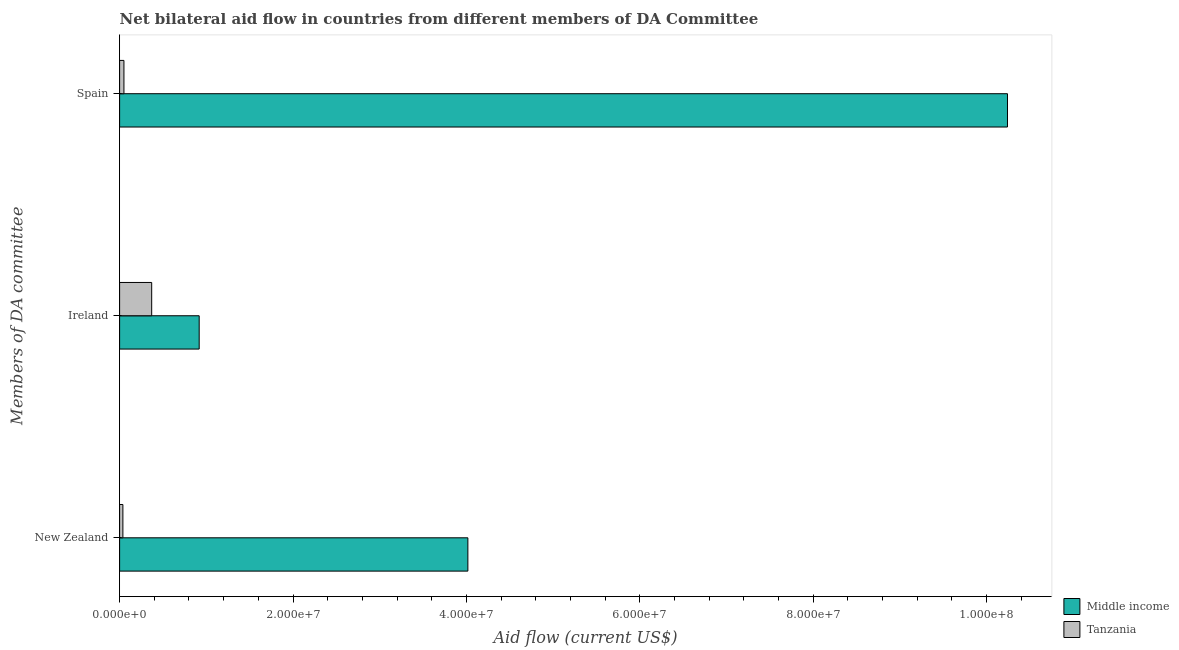Are the number of bars on each tick of the Y-axis equal?
Give a very brief answer. Yes. What is the amount of aid provided by new zealand in Middle income?
Ensure brevity in your answer.  4.02e+07. Across all countries, what is the maximum amount of aid provided by new zealand?
Keep it short and to the point. 4.02e+07. Across all countries, what is the minimum amount of aid provided by ireland?
Keep it short and to the point. 3.70e+06. In which country was the amount of aid provided by ireland maximum?
Provide a short and direct response. Middle income. In which country was the amount of aid provided by spain minimum?
Keep it short and to the point. Tanzania. What is the total amount of aid provided by spain in the graph?
Your answer should be compact. 1.03e+08. What is the difference between the amount of aid provided by new zealand in Tanzania and that in Middle income?
Offer a terse response. -3.98e+07. What is the difference between the amount of aid provided by new zealand in Tanzania and the amount of aid provided by ireland in Middle income?
Your answer should be very brief. -8.80e+06. What is the average amount of aid provided by spain per country?
Keep it short and to the point. 5.15e+07. What is the difference between the amount of aid provided by ireland and amount of aid provided by new zealand in Middle income?
Your answer should be compact. -3.10e+07. In how many countries, is the amount of aid provided by spain greater than 36000000 US$?
Provide a succinct answer. 1. What is the ratio of the amount of aid provided by spain in Tanzania to that in Middle income?
Make the answer very short. 0. Is the amount of aid provided by new zealand in Middle income less than that in Tanzania?
Your answer should be very brief. No. What is the difference between the highest and the second highest amount of aid provided by spain?
Your answer should be very brief. 1.02e+08. What is the difference between the highest and the lowest amount of aid provided by new zealand?
Offer a terse response. 3.98e+07. In how many countries, is the amount of aid provided by spain greater than the average amount of aid provided by spain taken over all countries?
Your response must be concise. 1. What does the 1st bar from the top in New Zealand represents?
Offer a terse response. Tanzania. What does the 2nd bar from the bottom in New Zealand represents?
Your response must be concise. Tanzania. How many bars are there?
Your response must be concise. 6. Are all the bars in the graph horizontal?
Offer a terse response. Yes. What is the difference between two consecutive major ticks on the X-axis?
Provide a succinct answer. 2.00e+07. Where does the legend appear in the graph?
Your response must be concise. Bottom right. How are the legend labels stacked?
Make the answer very short. Vertical. What is the title of the graph?
Offer a terse response. Net bilateral aid flow in countries from different members of DA Committee. What is the label or title of the X-axis?
Ensure brevity in your answer.  Aid flow (current US$). What is the label or title of the Y-axis?
Keep it short and to the point. Members of DA committee. What is the Aid flow (current US$) of Middle income in New Zealand?
Provide a short and direct response. 4.02e+07. What is the Aid flow (current US$) in Tanzania in New Zealand?
Ensure brevity in your answer.  3.80e+05. What is the Aid flow (current US$) in Middle income in Ireland?
Offer a terse response. 9.18e+06. What is the Aid flow (current US$) in Tanzania in Ireland?
Offer a very short reply. 3.70e+06. What is the Aid flow (current US$) of Middle income in Spain?
Make the answer very short. 1.02e+08. Across all Members of DA committee, what is the maximum Aid flow (current US$) of Middle income?
Your answer should be compact. 1.02e+08. Across all Members of DA committee, what is the maximum Aid flow (current US$) of Tanzania?
Keep it short and to the point. 3.70e+06. Across all Members of DA committee, what is the minimum Aid flow (current US$) of Middle income?
Ensure brevity in your answer.  9.18e+06. Across all Members of DA committee, what is the minimum Aid flow (current US$) in Tanzania?
Your answer should be very brief. 3.80e+05. What is the total Aid flow (current US$) in Middle income in the graph?
Provide a succinct answer. 1.52e+08. What is the total Aid flow (current US$) in Tanzania in the graph?
Your response must be concise. 4.58e+06. What is the difference between the Aid flow (current US$) of Middle income in New Zealand and that in Ireland?
Make the answer very short. 3.10e+07. What is the difference between the Aid flow (current US$) of Tanzania in New Zealand and that in Ireland?
Your answer should be very brief. -3.32e+06. What is the difference between the Aid flow (current US$) in Middle income in New Zealand and that in Spain?
Your answer should be compact. -6.22e+07. What is the difference between the Aid flow (current US$) in Tanzania in New Zealand and that in Spain?
Provide a succinct answer. -1.20e+05. What is the difference between the Aid flow (current US$) of Middle income in Ireland and that in Spain?
Provide a succinct answer. -9.32e+07. What is the difference between the Aid flow (current US$) of Tanzania in Ireland and that in Spain?
Offer a terse response. 3.20e+06. What is the difference between the Aid flow (current US$) of Middle income in New Zealand and the Aid flow (current US$) of Tanzania in Ireland?
Provide a succinct answer. 3.65e+07. What is the difference between the Aid flow (current US$) in Middle income in New Zealand and the Aid flow (current US$) in Tanzania in Spain?
Offer a terse response. 3.97e+07. What is the difference between the Aid flow (current US$) of Middle income in Ireland and the Aid flow (current US$) of Tanzania in Spain?
Give a very brief answer. 8.68e+06. What is the average Aid flow (current US$) in Middle income per Members of DA committee?
Offer a terse response. 5.06e+07. What is the average Aid flow (current US$) in Tanzania per Members of DA committee?
Offer a terse response. 1.53e+06. What is the difference between the Aid flow (current US$) of Middle income and Aid flow (current US$) of Tanzania in New Zealand?
Ensure brevity in your answer.  3.98e+07. What is the difference between the Aid flow (current US$) in Middle income and Aid flow (current US$) in Tanzania in Ireland?
Give a very brief answer. 5.48e+06. What is the difference between the Aid flow (current US$) of Middle income and Aid flow (current US$) of Tanzania in Spain?
Give a very brief answer. 1.02e+08. What is the ratio of the Aid flow (current US$) in Middle income in New Zealand to that in Ireland?
Provide a succinct answer. 4.38. What is the ratio of the Aid flow (current US$) of Tanzania in New Zealand to that in Ireland?
Provide a succinct answer. 0.1. What is the ratio of the Aid flow (current US$) of Middle income in New Zealand to that in Spain?
Provide a succinct answer. 0.39. What is the ratio of the Aid flow (current US$) of Tanzania in New Zealand to that in Spain?
Provide a succinct answer. 0.76. What is the ratio of the Aid flow (current US$) of Middle income in Ireland to that in Spain?
Provide a short and direct response. 0.09. What is the ratio of the Aid flow (current US$) in Tanzania in Ireland to that in Spain?
Your response must be concise. 7.4. What is the difference between the highest and the second highest Aid flow (current US$) in Middle income?
Offer a terse response. 6.22e+07. What is the difference between the highest and the second highest Aid flow (current US$) of Tanzania?
Your answer should be very brief. 3.20e+06. What is the difference between the highest and the lowest Aid flow (current US$) in Middle income?
Give a very brief answer. 9.32e+07. What is the difference between the highest and the lowest Aid flow (current US$) in Tanzania?
Ensure brevity in your answer.  3.32e+06. 